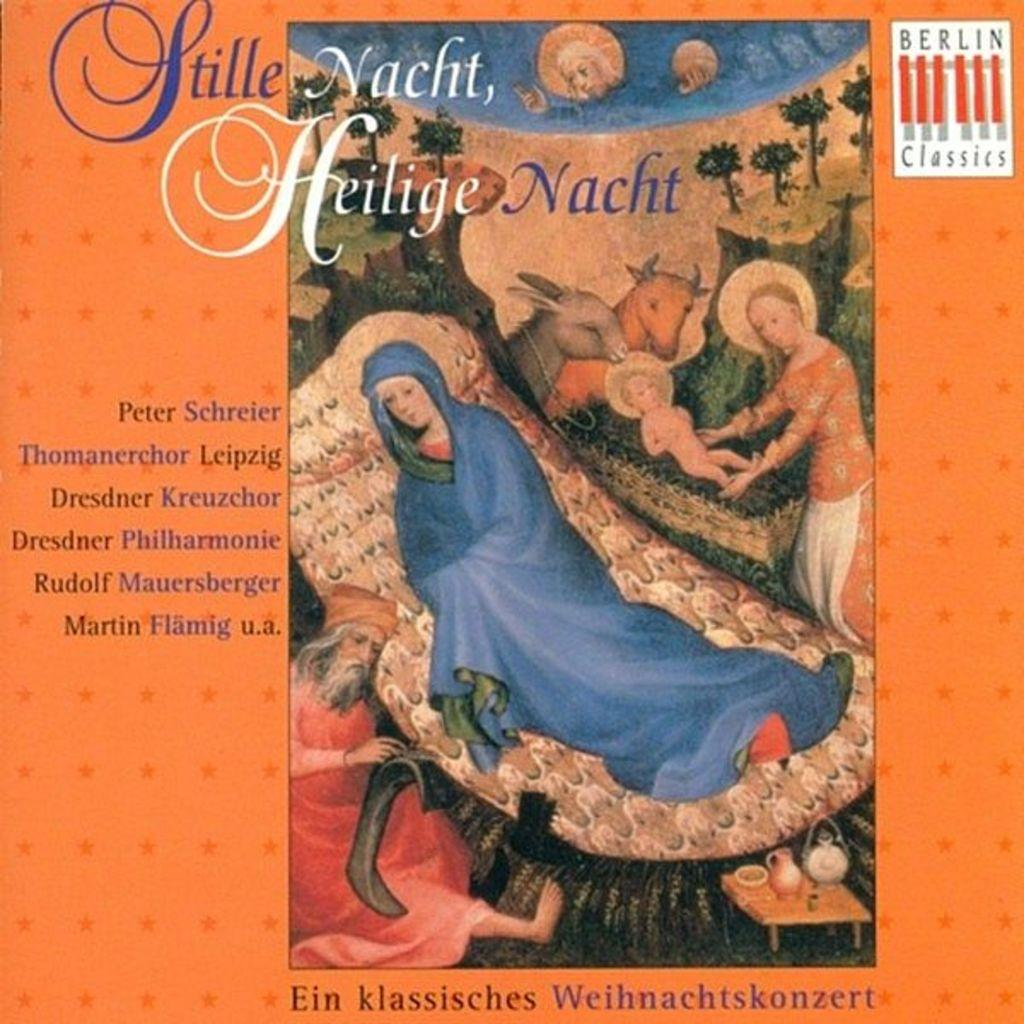<image>
Present a compact description of the photo's key features. Stille Nacht, Heilige Nacht created by Peter Schreier and is Berlin Classics. 